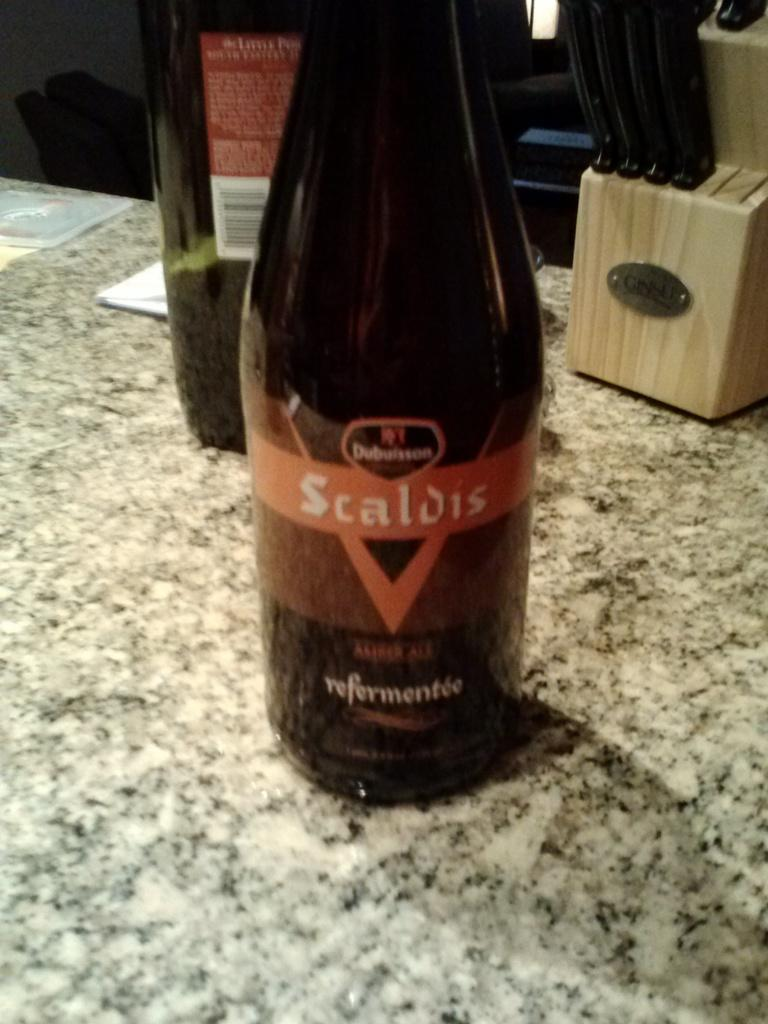Provide a one-sentence caption for the provided image. A bottle of Scaldis sits on a stone counter. 